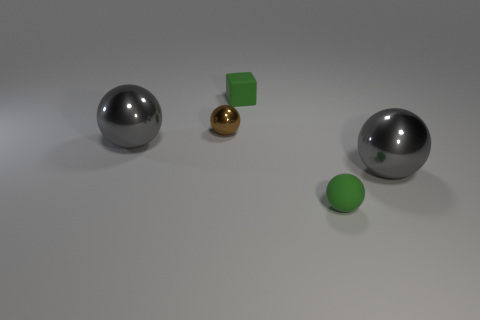Add 3 gray metal balls. How many objects exist? 8 Subtract all balls. How many objects are left? 1 Subtract all green matte things. Subtract all tiny brown balls. How many objects are left? 2 Add 1 brown things. How many brown things are left? 2 Add 5 tiny brown things. How many tiny brown things exist? 6 Subtract 0 yellow blocks. How many objects are left? 5 